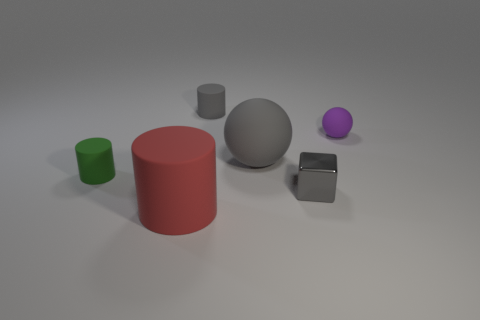Does the big cylinder have the same material as the small sphere?
Keep it short and to the point. Yes. Are there any other things that are the same material as the small gray cylinder?
Give a very brief answer. Yes. What material is the small gray thing that is the same shape as the tiny green object?
Provide a short and direct response. Rubber. Are there fewer gray matte cylinders that are on the left side of the red cylinder than small brown rubber blocks?
Your answer should be compact. No. How many large gray spheres are behind the gray ball?
Your response must be concise. 0. There is a object behind the small purple rubber thing; does it have the same shape as the large object that is left of the large gray sphere?
Your answer should be very brief. Yes. There is a object that is both right of the big red matte cylinder and in front of the small green matte object; what is its shape?
Ensure brevity in your answer.  Cube. The gray cylinder that is made of the same material as the purple ball is what size?
Provide a short and direct response. Small. Are there fewer green cylinders than small cylinders?
Give a very brief answer. Yes. What is the material of the red cylinder that is left of the small rubber cylinder behind the small cylinder that is in front of the gray cylinder?
Offer a terse response. Rubber. 